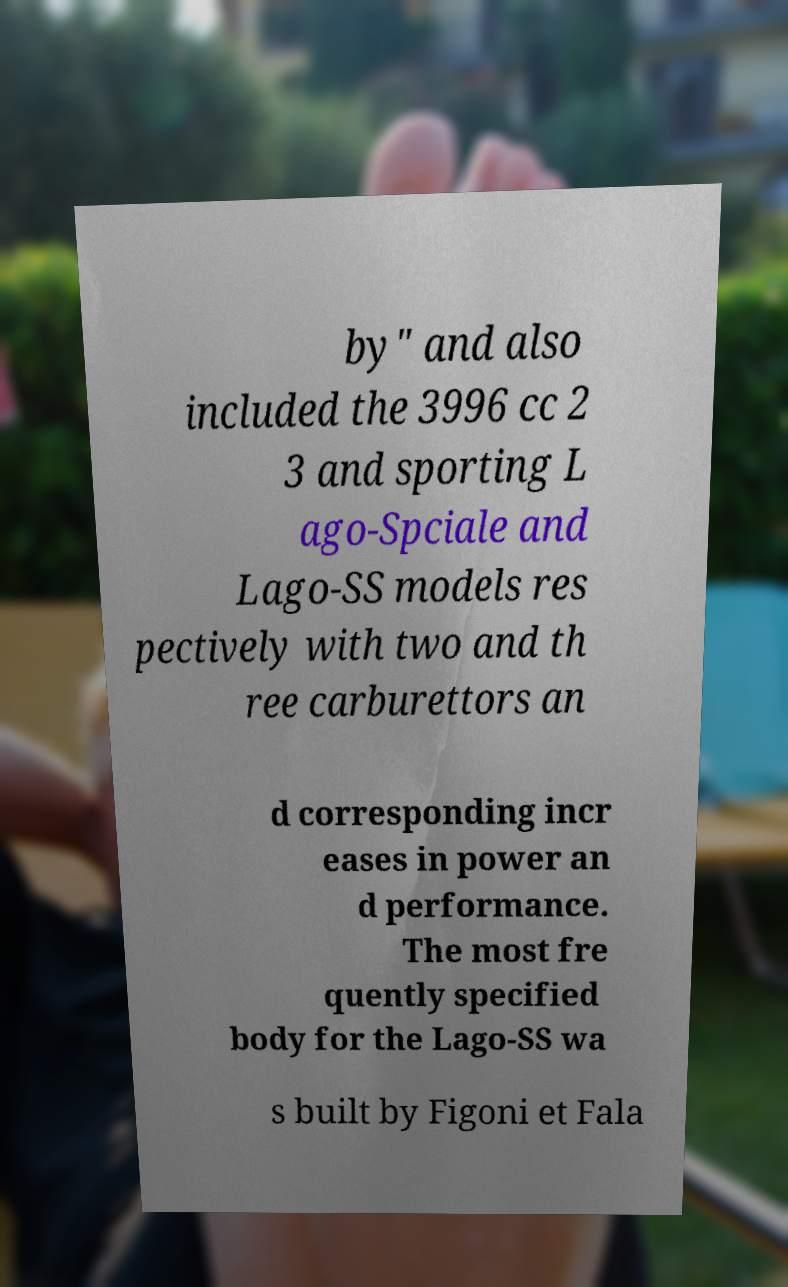Could you extract and type out the text from this image? by" and also included the 3996 cc 2 3 and sporting L ago-Spciale and Lago-SS models res pectively with two and th ree carburettors an d corresponding incr eases in power an d performance. The most fre quently specified body for the Lago-SS wa s built by Figoni et Fala 